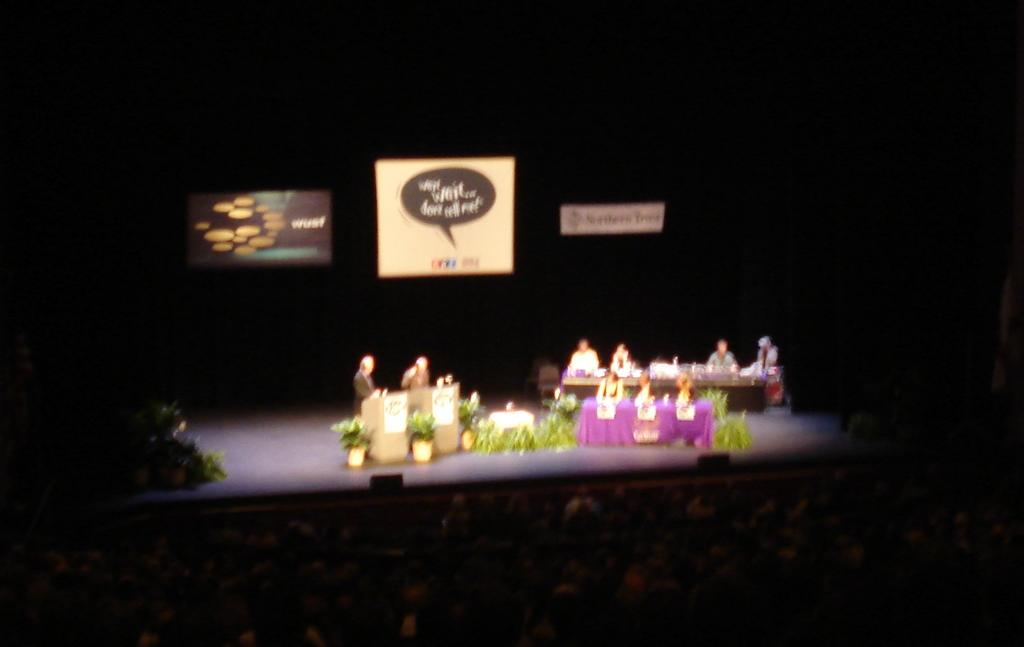How many people are in the image? There is a group of people in the image, but the exact number cannot be determined from the provided facts. What is the main feature of the image? The main feature of the image is a stage. What else can be seen on the stage besides the people? There are podiums on the stage. What other objects are present in the image? There are tables and plants in the image. What might be used for displaying information or visuals in the image? There is a screen in the image. What type of glue is being used to hold the yoke together in the image? There is no yoke or glue present in the image; it features a group of people on a stage with podiums, tables, plants, and a screen. 